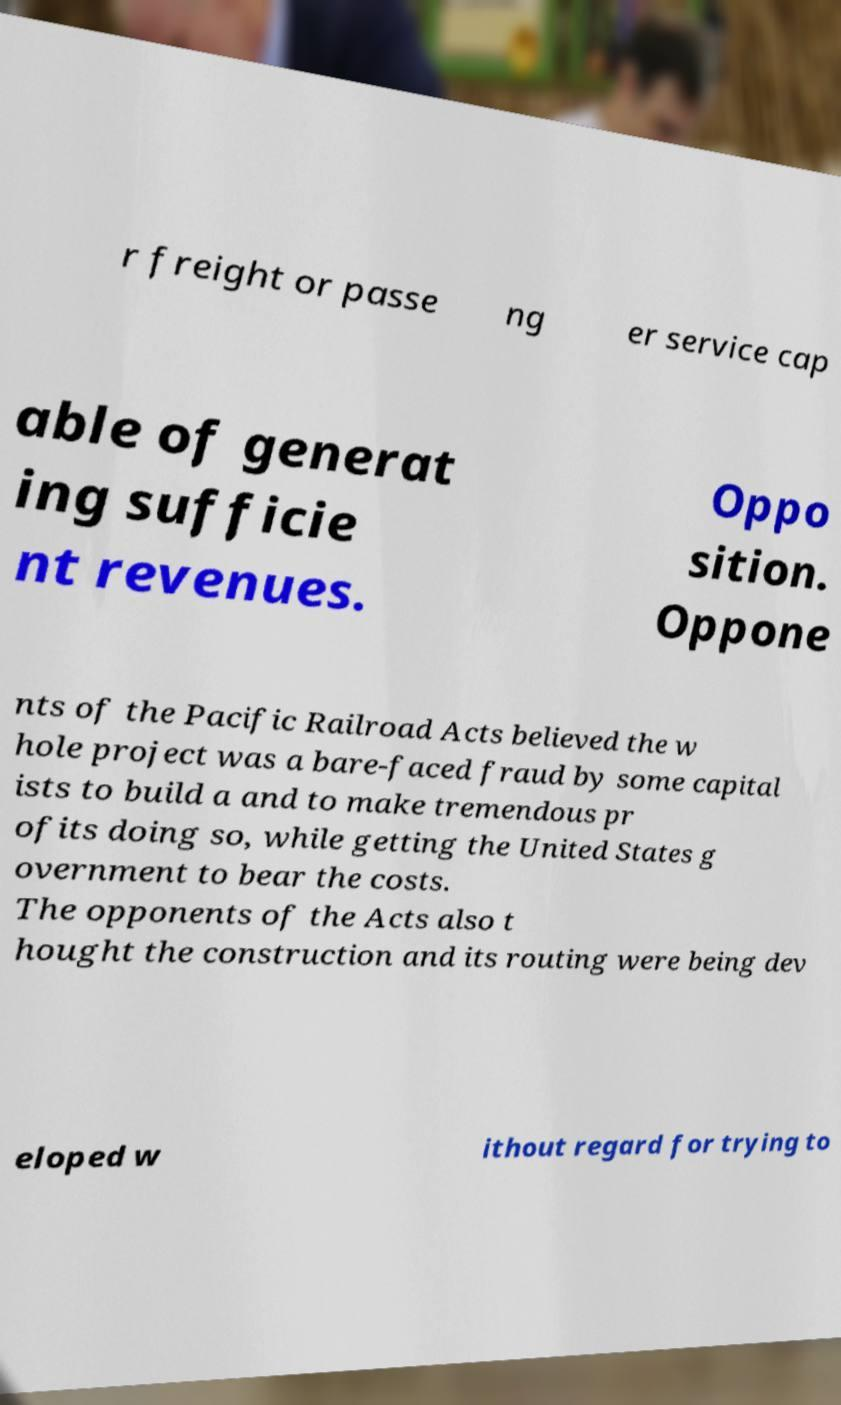What messages or text are displayed in this image? I need them in a readable, typed format. r freight or passe ng er service cap able of generat ing sufficie nt revenues. Oppo sition. Oppone nts of the Pacific Railroad Acts believed the w hole project was a bare-faced fraud by some capital ists to build a and to make tremendous pr ofits doing so, while getting the United States g overnment to bear the costs. The opponents of the Acts also t hought the construction and its routing were being dev eloped w ithout regard for trying to 